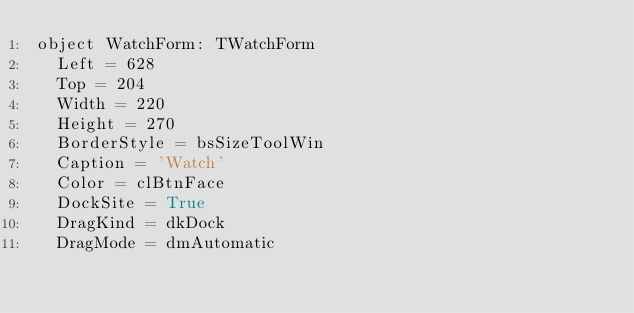Convert code to text. <code><loc_0><loc_0><loc_500><loc_500><_Pascal_>object WatchForm: TWatchForm
  Left = 628
  Top = 204
  Width = 220
  Height = 270
  BorderStyle = bsSizeToolWin
  Caption = 'Watch'
  Color = clBtnFace
  DockSite = True
  DragKind = dkDock
  DragMode = dmAutomatic</code> 